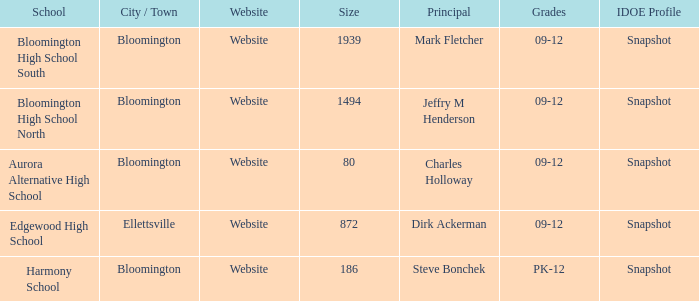Where's the school that Mark Fletcher is the principal of? Bloomington. 